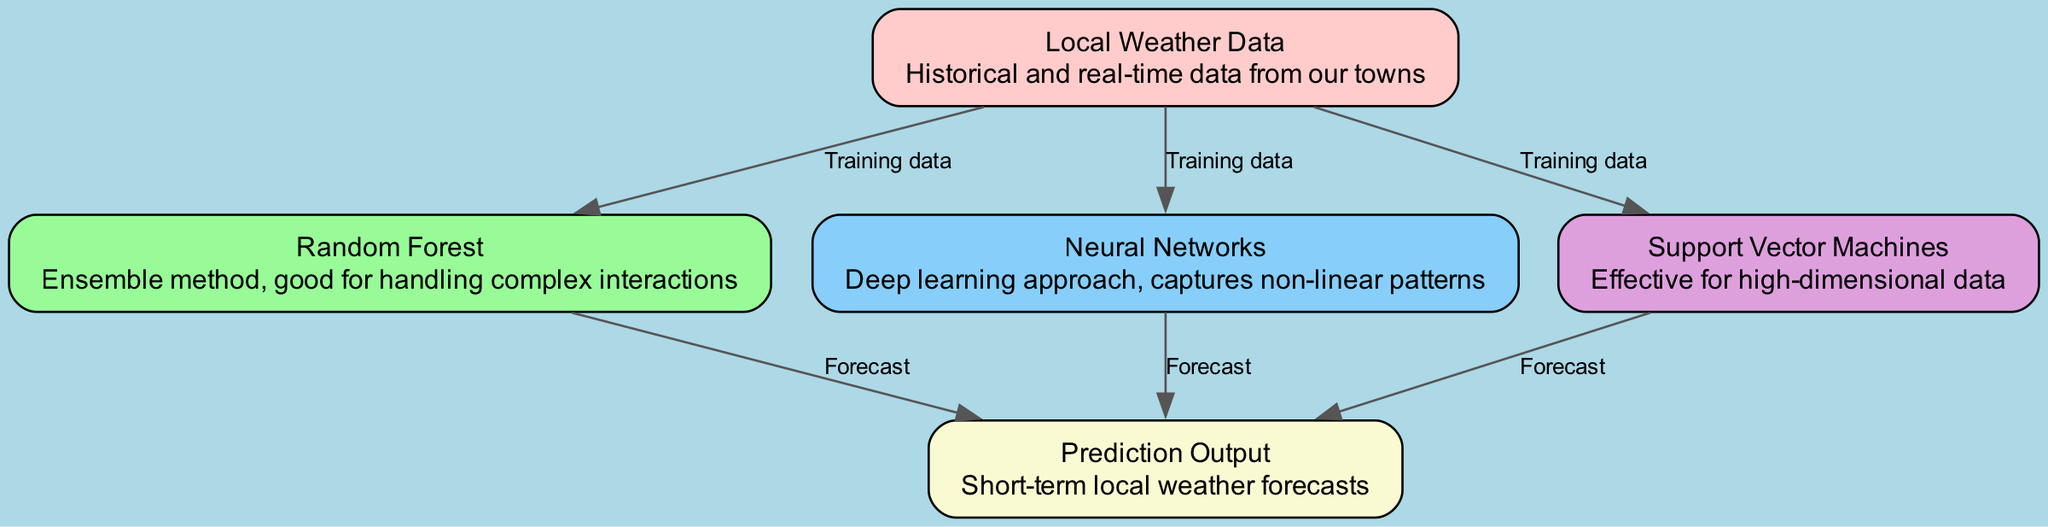What is the total number of nodes in the diagram? The diagram features a total of five nodes, which include Local Weather Data, Random Forest, Neural Networks, Support Vector Machines, and Prediction Output.
Answer: 5 What type of algorithm is used for handling complex interactions? According to the diagram, the Random Forest is identified as an ensemble method that is particularly effective for managing complex interactions among data variables.
Answer: Random Forest How many machine learning algorithms are shown in the diagram? The diagram indicates three machine learning algorithms: Random Forest, Neural Networks, and Support Vector Machines, as depicted within the nodes section.
Answer: 3 Which node represents the output of the weather prediction? The Prediction Output node is highlighted in the diagram as the final output generated by the machine learning algorithms after processing the input data.
Answer: Prediction Output What is the relationship between Local Weather Data and Support Vector Machines? The diagram clearly shows that Local Weather Data provides the necessary training data input for the Support Vector Machines algorithm to generate forecasts.
Answer: Training data How many edges connect the algorithms to the prediction output? There are three edges extending from the algorithms—Random Forest, Neural Networks, and Support Vector Machines—each leading to the Prediction Output, indicating that all contribute to its forecasts.
Answer: 3 What does the Neural Networks node capture in the context of weather prediction? The diagram elucidates that the Neural Networks node is particularly focused on capturing non-linear patterns within the training data, which is vital for accurate weather predictions.
Answer: Non-linear patterns Which algorithm is effective for high-dimensional data? The diagram specifies that Support Vector Machines is recognized as effective for handling high-dimensional data, making it a suitable choice for weather prediction based on complex datasets.
Answer: Support Vector Machines What color represents the Random Forest node in the diagram? The Random Forest node is represented in pale green within the diagram, distinguishing it visually from other nodes.
Answer: Pale Green 